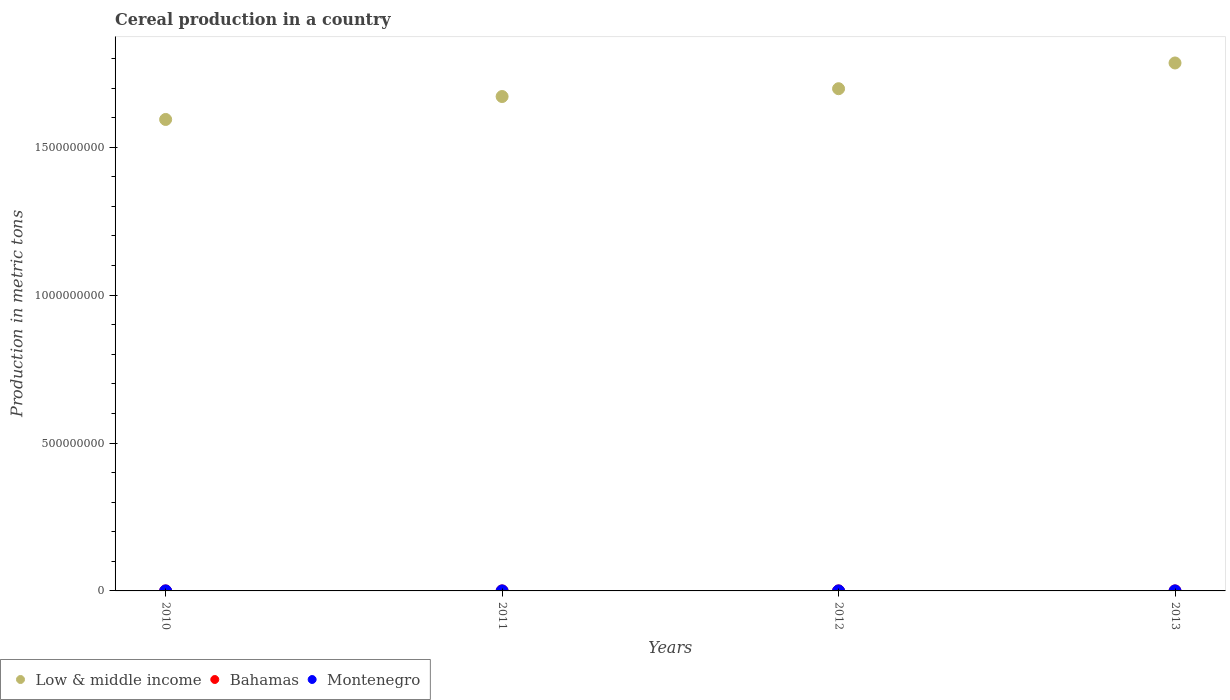What is the total cereal production in Low & middle income in 2013?
Provide a succinct answer. 1.78e+09. Across all years, what is the maximum total cereal production in Bahamas?
Keep it short and to the point. 700. Across all years, what is the minimum total cereal production in Bahamas?
Your answer should be very brief. 678. In which year was the total cereal production in Low & middle income maximum?
Your answer should be compact. 2013. In which year was the total cereal production in Bahamas minimum?
Provide a succinct answer. 2010. What is the total total cereal production in Low & middle income in the graph?
Provide a succinct answer. 6.75e+09. What is the difference between the total cereal production in Montenegro in 2010 and that in 2013?
Give a very brief answer. 2408. What is the difference between the total cereal production in Low & middle income in 2010 and the total cereal production in Bahamas in 2012?
Provide a succinct answer. 1.59e+09. What is the average total cereal production in Bahamas per year?
Give a very brief answer. 688.75. In the year 2010, what is the difference between the total cereal production in Bahamas and total cereal production in Montenegro?
Your answer should be very brief. -1.56e+04. What is the ratio of the total cereal production in Montenegro in 2010 to that in 2011?
Make the answer very short. 0.93. Is the total cereal production in Montenegro in 2011 less than that in 2012?
Make the answer very short. No. What is the difference between the highest and the second highest total cereal production in Montenegro?
Provide a succinct answer. 1243. What is the difference between the highest and the lowest total cereal production in Montenegro?
Offer a very short reply. 4168. In how many years, is the total cereal production in Montenegro greater than the average total cereal production in Montenegro taken over all years?
Provide a short and direct response. 2. Is the sum of the total cereal production in Montenegro in 2012 and 2013 greater than the maximum total cereal production in Bahamas across all years?
Ensure brevity in your answer.  Yes. Does the total cereal production in Low & middle income monotonically increase over the years?
Your answer should be very brief. Yes. Is the total cereal production in Bahamas strictly greater than the total cereal production in Low & middle income over the years?
Your answer should be compact. No. Is the total cereal production in Bahamas strictly less than the total cereal production in Montenegro over the years?
Ensure brevity in your answer.  Yes. How many years are there in the graph?
Make the answer very short. 4. Are the values on the major ticks of Y-axis written in scientific E-notation?
Make the answer very short. No. Does the graph contain grids?
Provide a short and direct response. No. How many legend labels are there?
Provide a short and direct response. 3. How are the legend labels stacked?
Provide a succinct answer. Horizontal. What is the title of the graph?
Keep it short and to the point. Cereal production in a country. Does "Armenia" appear as one of the legend labels in the graph?
Your response must be concise. No. What is the label or title of the X-axis?
Make the answer very short. Years. What is the label or title of the Y-axis?
Make the answer very short. Production in metric tons. What is the Production in metric tons in Low & middle income in 2010?
Offer a terse response. 1.59e+09. What is the Production in metric tons of Bahamas in 2010?
Keep it short and to the point. 678. What is the Production in metric tons in Montenegro in 2010?
Offer a very short reply. 1.63e+04. What is the Production in metric tons in Low & middle income in 2011?
Your response must be concise. 1.67e+09. What is the Production in metric tons of Bahamas in 2011?
Ensure brevity in your answer.  687. What is the Production in metric tons in Montenegro in 2011?
Offer a very short reply. 1.75e+04. What is the Production in metric tons of Low & middle income in 2012?
Make the answer very short. 1.70e+09. What is the Production in metric tons in Bahamas in 2012?
Your response must be concise. 690. What is the Production in metric tons in Montenegro in 2012?
Your answer should be compact. 1.33e+04. What is the Production in metric tons of Low & middle income in 2013?
Offer a very short reply. 1.78e+09. What is the Production in metric tons of Bahamas in 2013?
Your answer should be compact. 700. What is the Production in metric tons of Montenegro in 2013?
Offer a very short reply. 1.38e+04. Across all years, what is the maximum Production in metric tons of Low & middle income?
Offer a very short reply. 1.78e+09. Across all years, what is the maximum Production in metric tons of Bahamas?
Provide a succinct answer. 700. Across all years, what is the maximum Production in metric tons in Montenegro?
Provide a succinct answer. 1.75e+04. Across all years, what is the minimum Production in metric tons of Low & middle income?
Ensure brevity in your answer.  1.59e+09. Across all years, what is the minimum Production in metric tons in Bahamas?
Ensure brevity in your answer.  678. Across all years, what is the minimum Production in metric tons of Montenegro?
Make the answer very short. 1.33e+04. What is the total Production in metric tons of Low & middle income in the graph?
Give a very brief answer. 6.75e+09. What is the total Production in metric tons in Bahamas in the graph?
Your answer should be compact. 2755. What is the total Production in metric tons of Montenegro in the graph?
Make the answer very short. 6.09e+04. What is the difference between the Production in metric tons of Low & middle income in 2010 and that in 2011?
Offer a very short reply. -7.75e+07. What is the difference between the Production in metric tons of Montenegro in 2010 and that in 2011?
Your response must be concise. -1243. What is the difference between the Production in metric tons of Low & middle income in 2010 and that in 2012?
Keep it short and to the point. -1.04e+08. What is the difference between the Production in metric tons in Montenegro in 2010 and that in 2012?
Ensure brevity in your answer.  2925. What is the difference between the Production in metric tons in Low & middle income in 2010 and that in 2013?
Offer a terse response. -1.91e+08. What is the difference between the Production in metric tons in Montenegro in 2010 and that in 2013?
Provide a succinct answer. 2408. What is the difference between the Production in metric tons in Low & middle income in 2011 and that in 2012?
Provide a succinct answer. -2.64e+07. What is the difference between the Production in metric tons in Bahamas in 2011 and that in 2012?
Your response must be concise. -3. What is the difference between the Production in metric tons of Montenegro in 2011 and that in 2012?
Give a very brief answer. 4168. What is the difference between the Production in metric tons in Low & middle income in 2011 and that in 2013?
Your answer should be very brief. -1.13e+08. What is the difference between the Production in metric tons in Montenegro in 2011 and that in 2013?
Your response must be concise. 3651. What is the difference between the Production in metric tons in Low & middle income in 2012 and that in 2013?
Ensure brevity in your answer.  -8.70e+07. What is the difference between the Production in metric tons of Montenegro in 2012 and that in 2013?
Give a very brief answer. -517. What is the difference between the Production in metric tons in Low & middle income in 2010 and the Production in metric tons in Bahamas in 2011?
Provide a short and direct response. 1.59e+09. What is the difference between the Production in metric tons in Low & middle income in 2010 and the Production in metric tons in Montenegro in 2011?
Your response must be concise. 1.59e+09. What is the difference between the Production in metric tons of Bahamas in 2010 and the Production in metric tons of Montenegro in 2011?
Provide a succinct answer. -1.68e+04. What is the difference between the Production in metric tons in Low & middle income in 2010 and the Production in metric tons in Bahamas in 2012?
Give a very brief answer. 1.59e+09. What is the difference between the Production in metric tons in Low & middle income in 2010 and the Production in metric tons in Montenegro in 2012?
Ensure brevity in your answer.  1.59e+09. What is the difference between the Production in metric tons in Bahamas in 2010 and the Production in metric tons in Montenegro in 2012?
Ensure brevity in your answer.  -1.27e+04. What is the difference between the Production in metric tons of Low & middle income in 2010 and the Production in metric tons of Bahamas in 2013?
Your answer should be compact. 1.59e+09. What is the difference between the Production in metric tons in Low & middle income in 2010 and the Production in metric tons in Montenegro in 2013?
Keep it short and to the point. 1.59e+09. What is the difference between the Production in metric tons in Bahamas in 2010 and the Production in metric tons in Montenegro in 2013?
Your answer should be compact. -1.32e+04. What is the difference between the Production in metric tons in Low & middle income in 2011 and the Production in metric tons in Bahamas in 2012?
Provide a short and direct response. 1.67e+09. What is the difference between the Production in metric tons of Low & middle income in 2011 and the Production in metric tons of Montenegro in 2012?
Offer a terse response. 1.67e+09. What is the difference between the Production in metric tons in Bahamas in 2011 and the Production in metric tons in Montenegro in 2012?
Offer a terse response. -1.26e+04. What is the difference between the Production in metric tons of Low & middle income in 2011 and the Production in metric tons of Bahamas in 2013?
Keep it short and to the point. 1.67e+09. What is the difference between the Production in metric tons in Low & middle income in 2011 and the Production in metric tons in Montenegro in 2013?
Offer a terse response. 1.67e+09. What is the difference between the Production in metric tons of Bahamas in 2011 and the Production in metric tons of Montenegro in 2013?
Ensure brevity in your answer.  -1.32e+04. What is the difference between the Production in metric tons in Low & middle income in 2012 and the Production in metric tons in Bahamas in 2013?
Your answer should be very brief. 1.70e+09. What is the difference between the Production in metric tons in Low & middle income in 2012 and the Production in metric tons in Montenegro in 2013?
Make the answer very short. 1.70e+09. What is the difference between the Production in metric tons of Bahamas in 2012 and the Production in metric tons of Montenegro in 2013?
Your answer should be compact. -1.32e+04. What is the average Production in metric tons in Low & middle income per year?
Provide a short and direct response. 1.69e+09. What is the average Production in metric tons in Bahamas per year?
Keep it short and to the point. 688.75. What is the average Production in metric tons in Montenegro per year?
Offer a very short reply. 1.52e+04. In the year 2010, what is the difference between the Production in metric tons of Low & middle income and Production in metric tons of Bahamas?
Offer a terse response. 1.59e+09. In the year 2010, what is the difference between the Production in metric tons in Low & middle income and Production in metric tons in Montenegro?
Make the answer very short. 1.59e+09. In the year 2010, what is the difference between the Production in metric tons of Bahamas and Production in metric tons of Montenegro?
Make the answer very short. -1.56e+04. In the year 2011, what is the difference between the Production in metric tons in Low & middle income and Production in metric tons in Bahamas?
Your answer should be very brief. 1.67e+09. In the year 2011, what is the difference between the Production in metric tons of Low & middle income and Production in metric tons of Montenegro?
Offer a terse response. 1.67e+09. In the year 2011, what is the difference between the Production in metric tons in Bahamas and Production in metric tons in Montenegro?
Offer a very short reply. -1.68e+04. In the year 2012, what is the difference between the Production in metric tons in Low & middle income and Production in metric tons in Bahamas?
Provide a succinct answer. 1.70e+09. In the year 2012, what is the difference between the Production in metric tons in Low & middle income and Production in metric tons in Montenegro?
Keep it short and to the point. 1.70e+09. In the year 2012, what is the difference between the Production in metric tons in Bahamas and Production in metric tons in Montenegro?
Your response must be concise. -1.26e+04. In the year 2013, what is the difference between the Production in metric tons of Low & middle income and Production in metric tons of Bahamas?
Provide a short and direct response. 1.78e+09. In the year 2013, what is the difference between the Production in metric tons of Low & middle income and Production in metric tons of Montenegro?
Offer a very short reply. 1.78e+09. In the year 2013, what is the difference between the Production in metric tons of Bahamas and Production in metric tons of Montenegro?
Offer a terse response. -1.32e+04. What is the ratio of the Production in metric tons of Low & middle income in 2010 to that in 2011?
Provide a succinct answer. 0.95. What is the ratio of the Production in metric tons in Bahamas in 2010 to that in 2011?
Make the answer very short. 0.99. What is the ratio of the Production in metric tons in Montenegro in 2010 to that in 2011?
Keep it short and to the point. 0.93. What is the ratio of the Production in metric tons in Low & middle income in 2010 to that in 2012?
Your response must be concise. 0.94. What is the ratio of the Production in metric tons of Bahamas in 2010 to that in 2012?
Your answer should be very brief. 0.98. What is the ratio of the Production in metric tons of Montenegro in 2010 to that in 2012?
Offer a terse response. 1.22. What is the ratio of the Production in metric tons of Low & middle income in 2010 to that in 2013?
Provide a short and direct response. 0.89. What is the ratio of the Production in metric tons of Bahamas in 2010 to that in 2013?
Your answer should be compact. 0.97. What is the ratio of the Production in metric tons of Montenegro in 2010 to that in 2013?
Your answer should be compact. 1.17. What is the ratio of the Production in metric tons of Low & middle income in 2011 to that in 2012?
Your answer should be compact. 0.98. What is the ratio of the Production in metric tons of Bahamas in 2011 to that in 2012?
Offer a terse response. 1. What is the ratio of the Production in metric tons of Montenegro in 2011 to that in 2012?
Provide a succinct answer. 1.31. What is the ratio of the Production in metric tons in Low & middle income in 2011 to that in 2013?
Your response must be concise. 0.94. What is the ratio of the Production in metric tons of Bahamas in 2011 to that in 2013?
Provide a succinct answer. 0.98. What is the ratio of the Production in metric tons of Montenegro in 2011 to that in 2013?
Make the answer very short. 1.26. What is the ratio of the Production in metric tons of Low & middle income in 2012 to that in 2013?
Ensure brevity in your answer.  0.95. What is the ratio of the Production in metric tons of Bahamas in 2012 to that in 2013?
Offer a very short reply. 0.99. What is the ratio of the Production in metric tons of Montenegro in 2012 to that in 2013?
Provide a short and direct response. 0.96. What is the difference between the highest and the second highest Production in metric tons of Low & middle income?
Give a very brief answer. 8.70e+07. What is the difference between the highest and the second highest Production in metric tons of Bahamas?
Provide a short and direct response. 10. What is the difference between the highest and the second highest Production in metric tons in Montenegro?
Your answer should be compact. 1243. What is the difference between the highest and the lowest Production in metric tons in Low & middle income?
Provide a short and direct response. 1.91e+08. What is the difference between the highest and the lowest Production in metric tons in Bahamas?
Keep it short and to the point. 22. What is the difference between the highest and the lowest Production in metric tons in Montenegro?
Your answer should be very brief. 4168. 